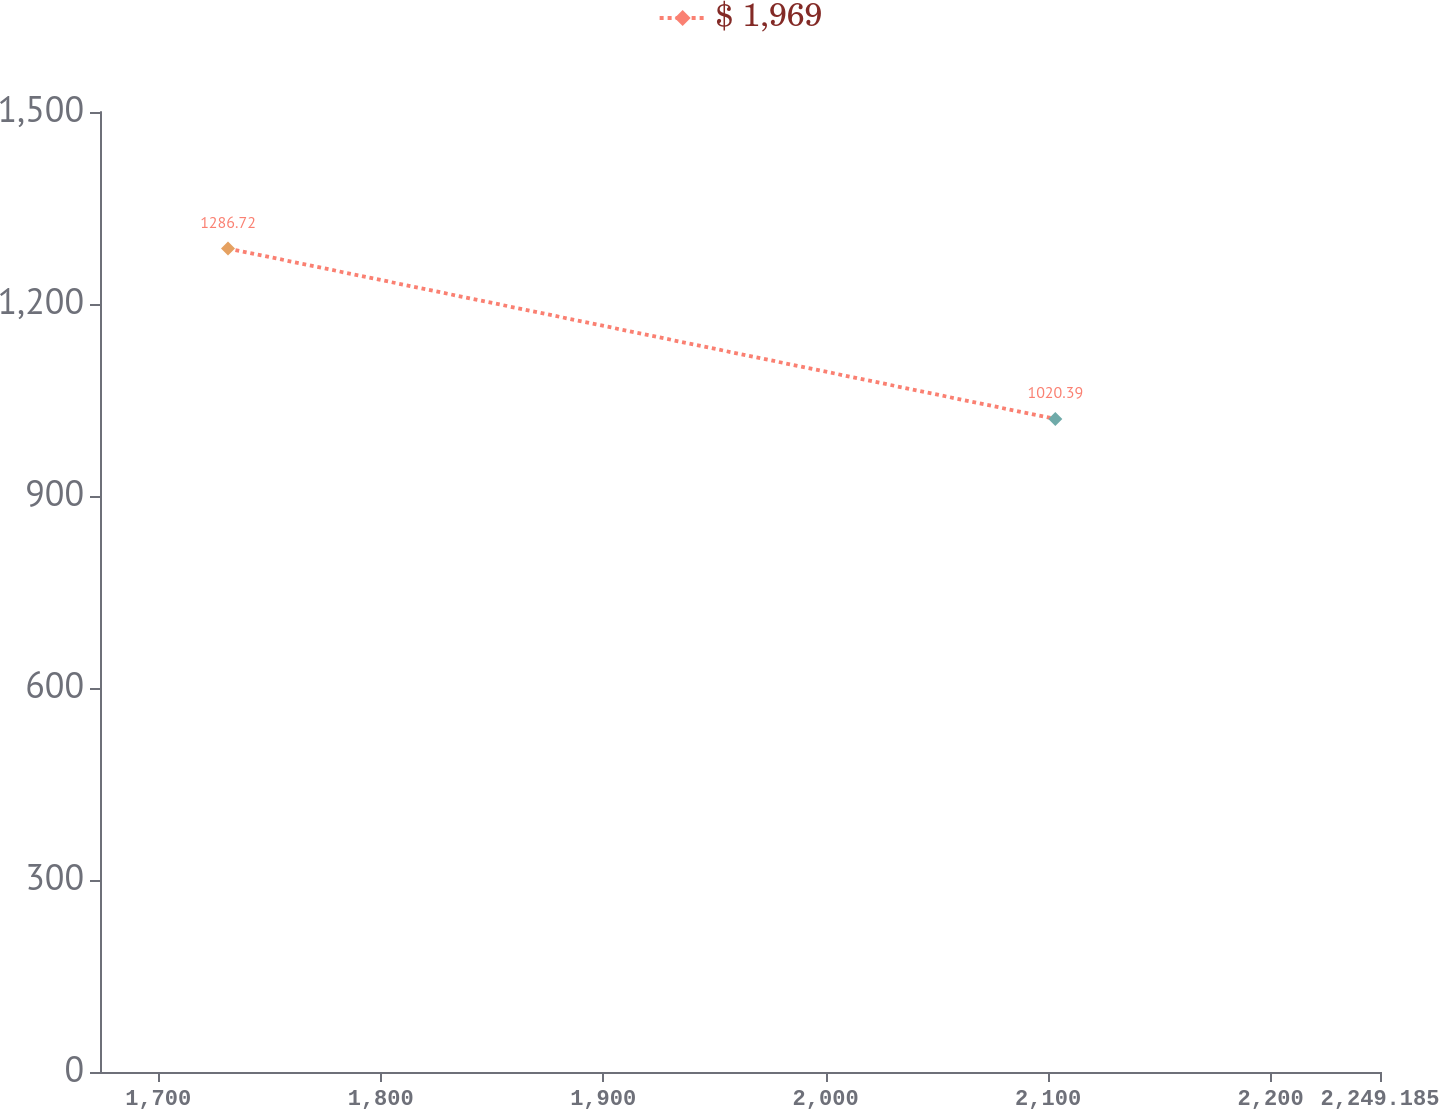Convert chart. <chart><loc_0><loc_0><loc_500><loc_500><line_chart><ecel><fcel>$ 1,969<nl><fcel>1731.37<fcel>1286.72<nl><fcel>2103.23<fcel>1020.39<nl><fcel>2250.24<fcel>1449.8<nl><fcel>2306.72<fcel>972.68<nl></chart> 